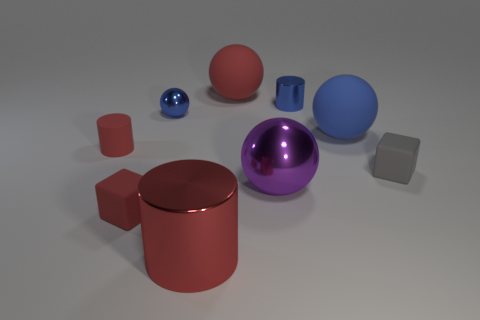There is a rubber object that is the same color as the tiny ball; what is its size?
Your answer should be very brief. Large. Are there more shiny balls that are to the left of the purple thing than large blue things?
Give a very brief answer. No. There is a large blue thing; does it have the same shape as the small rubber object right of the big red metallic cylinder?
Offer a very short reply. No. What number of other rubber spheres have the same size as the red matte ball?
Offer a very short reply. 1. There is a small metallic thing to the left of the small blue metal thing that is on the right side of the blue shiny sphere; how many big objects are in front of it?
Make the answer very short. 3. Are there the same number of small blocks that are to the right of the gray matte thing and metallic balls behind the red block?
Offer a very short reply. No. What number of small gray matte objects have the same shape as the blue rubber object?
Offer a terse response. 0. Are there any large brown objects that have the same material as the large red ball?
Make the answer very short. No. What is the shape of the small metal object that is the same color as the small sphere?
Your answer should be compact. Cylinder. What number of big purple metallic balls are there?
Make the answer very short. 1. 